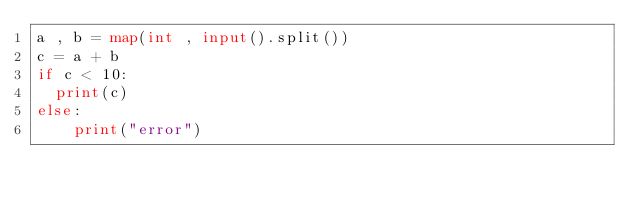<code> <loc_0><loc_0><loc_500><loc_500><_Python_>a , b = map(int , input().split())
c = a + b
if c < 10:
	print(c)
else:
		print("error")</code> 